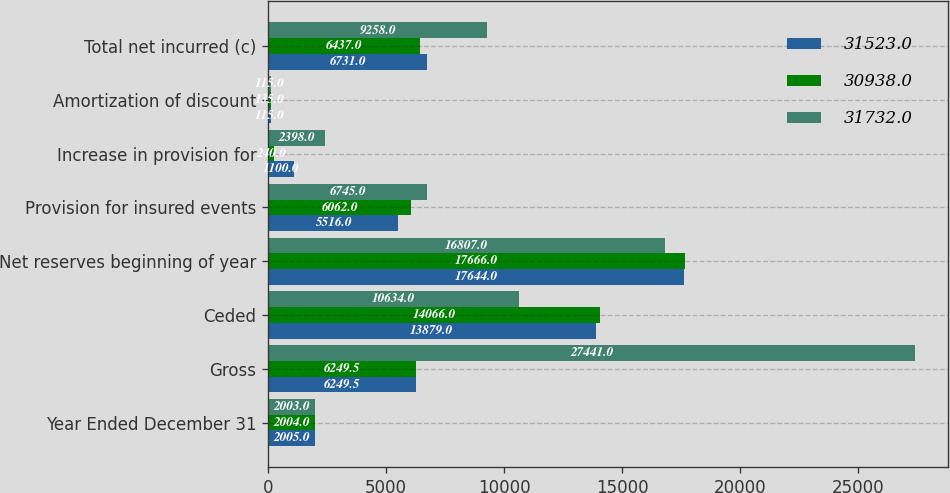Convert chart. <chart><loc_0><loc_0><loc_500><loc_500><stacked_bar_chart><ecel><fcel>Year Ended December 31<fcel>Gross<fcel>Ceded<fcel>Net reserves beginning of year<fcel>Provision for insured events<fcel>Increase in provision for<fcel>Amortization of discount<fcel>Total net incurred (c)<nl><fcel>31523<fcel>2005<fcel>6249.5<fcel>13879<fcel>17644<fcel>5516<fcel>1100<fcel>115<fcel>6731<nl><fcel>30938<fcel>2004<fcel>6249.5<fcel>14066<fcel>17666<fcel>6062<fcel>240<fcel>135<fcel>6437<nl><fcel>31732<fcel>2003<fcel>27441<fcel>10634<fcel>16807<fcel>6745<fcel>2398<fcel>115<fcel>9258<nl></chart> 